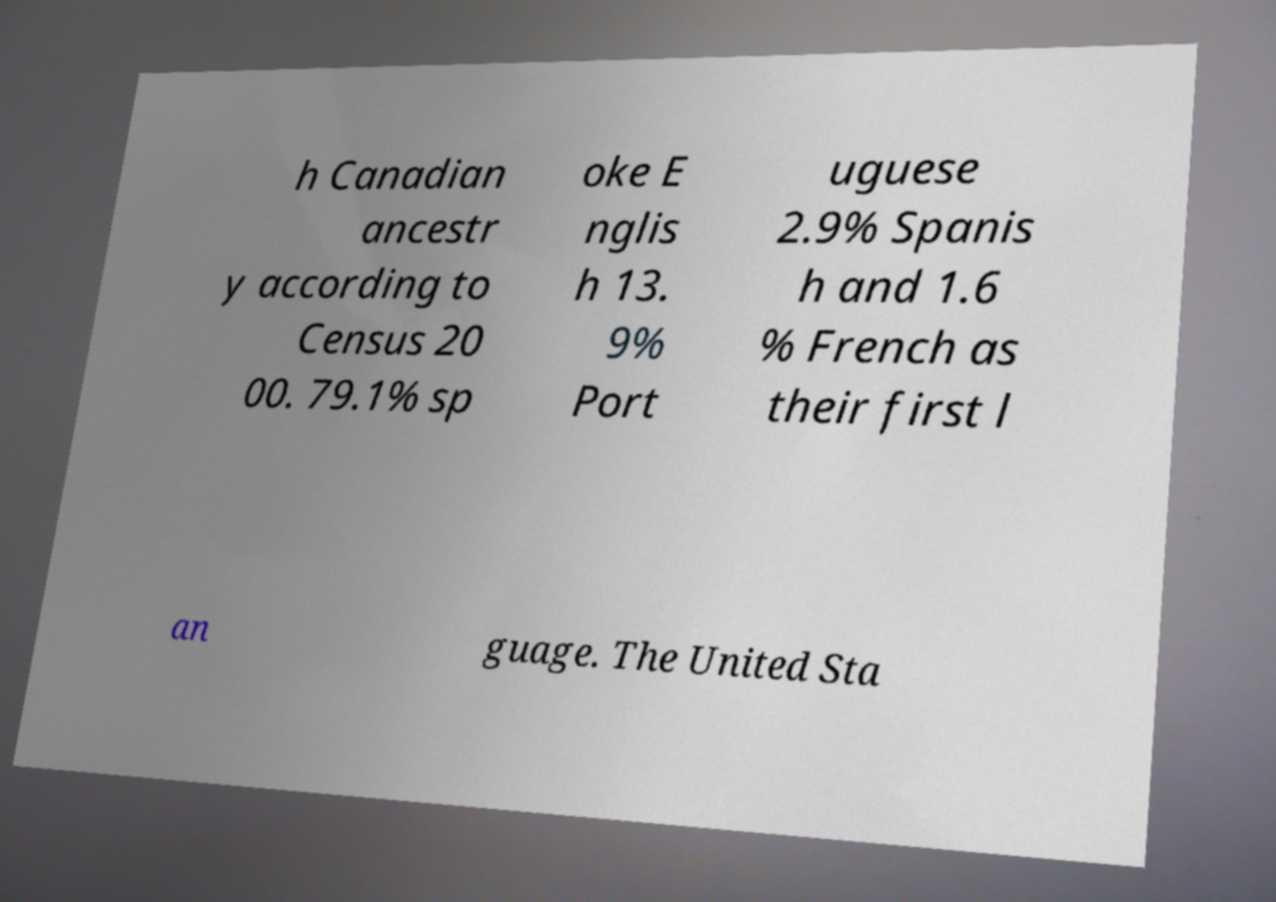What messages or text are displayed in this image? I need them in a readable, typed format. h Canadian ancestr y according to Census 20 00. 79.1% sp oke E nglis h 13. 9% Port uguese 2.9% Spanis h and 1.6 % French as their first l an guage. The United Sta 